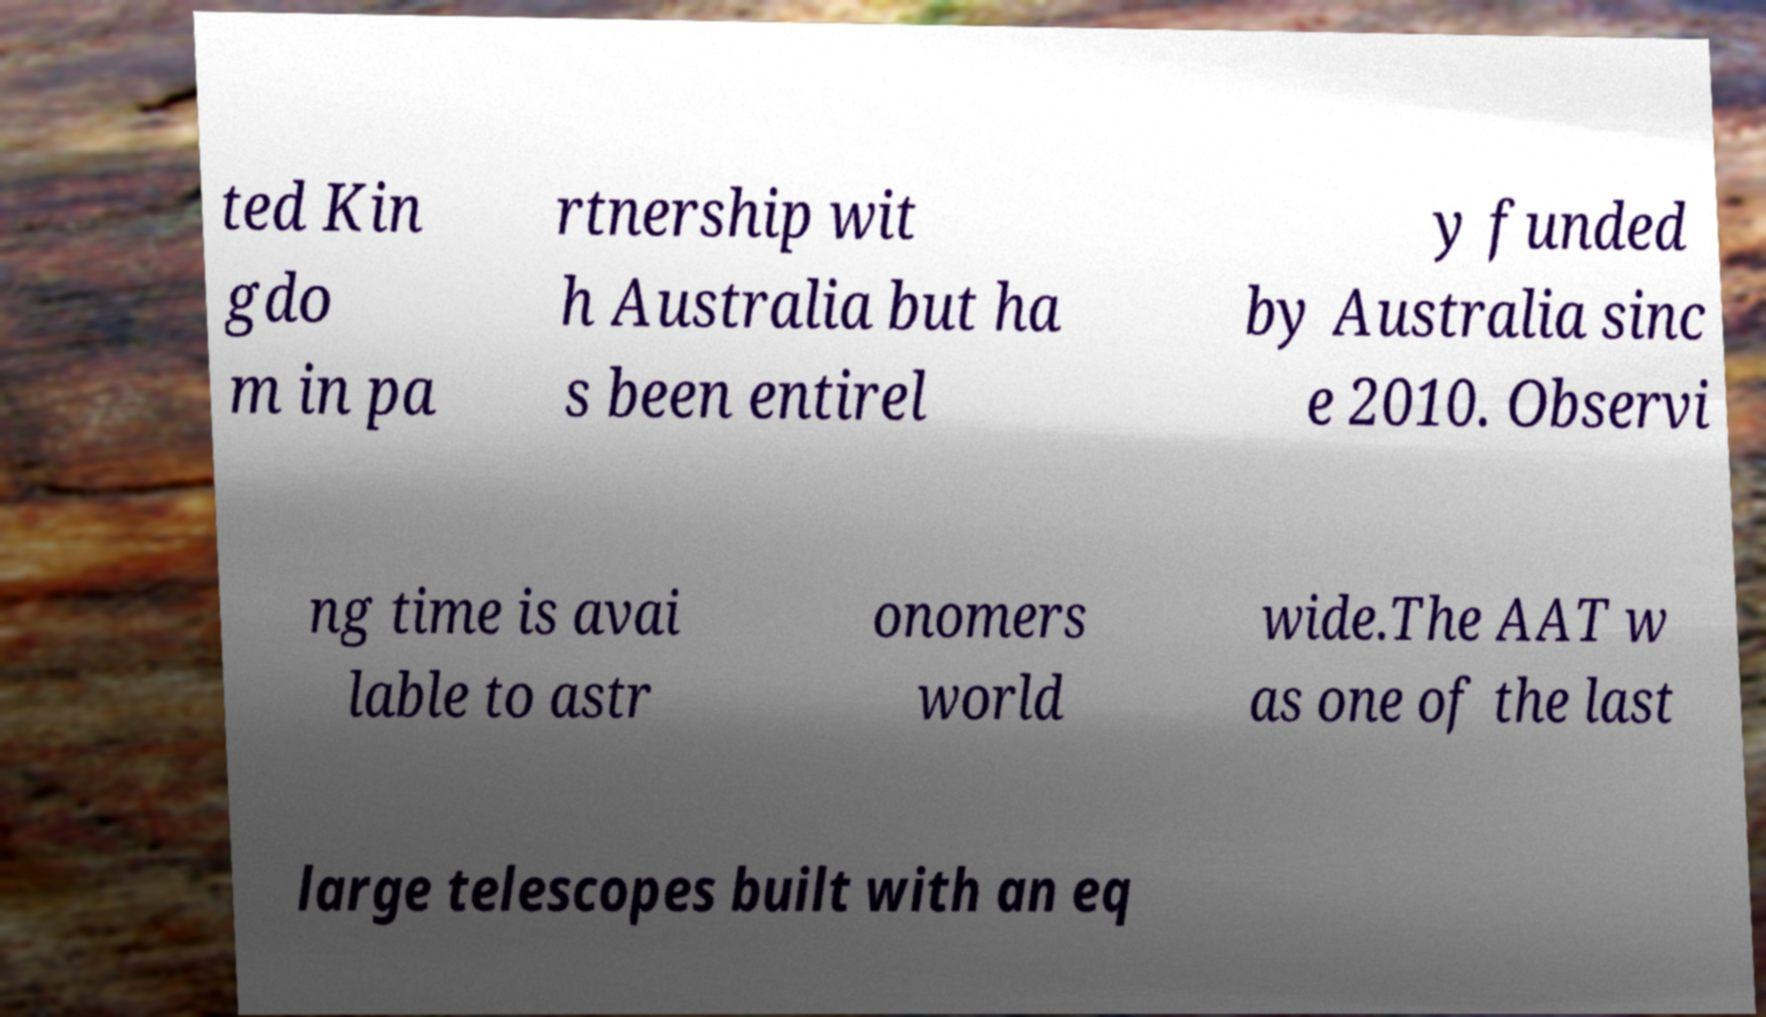Please read and relay the text visible in this image. What does it say? ted Kin gdo m in pa rtnership wit h Australia but ha s been entirel y funded by Australia sinc e 2010. Observi ng time is avai lable to astr onomers world wide.The AAT w as one of the last large telescopes built with an eq 